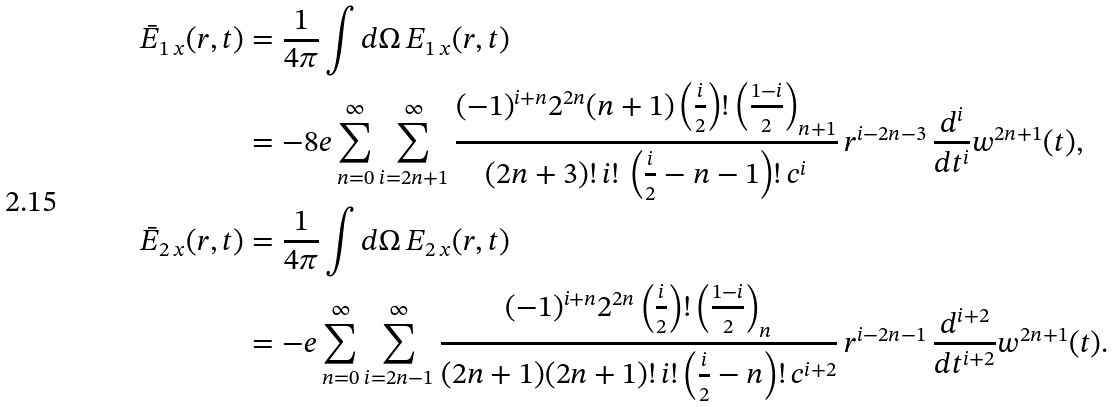<formula> <loc_0><loc_0><loc_500><loc_500>\bar { E } _ { 1 \, x } ( r , t ) & = \frac { 1 } { 4 \pi } \int d \Omega \, E _ { 1 \, x } ( { r } , t ) \\ & = - 8 e \sum _ { n = 0 } ^ { \infty } \sum _ { i = 2 n + 1 } ^ { \infty } \frac { ( - 1 ) ^ { i + n } 2 ^ { 2 n } ( n + 1 ) \left ( \frac { i } { 2 } \right ) ! \left ( \frac { 1 - i } { 2 } \right ) _ { n + 1 } } { ( 2 n + 3 ) ! \, i ! \, \left ( \frac { i } { 2 } - n - 1 \right ) ! \, c ^ { i } } \, r ^ { i - 2 n - 3 } \, \frac { d ^ { i } } { d t ^ { i } } w ^ { 2 n + 1 } ( t ) , \\ \bar { E } _ { 2 \, x } ( r , t ) & = \frac { 1 } { 4 \pi } \int d \Omega \, E _ { 2 \, x } ( { r } , t ) \\ & = - e \sum _ { n = 0 } ^ { \infty } \sum _ { i = 2 n - 1 } ^ { \infty } \frac { ( - 1 ) ^ { i + n } 2 ^ { 2 n } \left ( \frac { i } { 2 } \right ) ! \left ( \frac { 1 - i } { 2 } \right ) _ { n } } { ( 2 n + 1 ) ( 2 n + 1 ) ! \, i ! \left ( \frac { i } { 2 } - n \right ) ! \, c ^ { i + 2 } } \, r ^ { i - 2 n - 1 } \, \frac { d ^ { i + 2 } } { d t ^ { i + 2 } } w ^ { 2 n + 1 } ( t ) .</formula> 